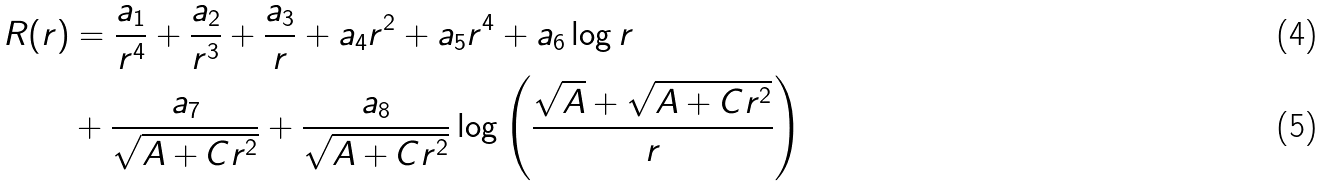<formula> <loc_0><loc_0><loc_500><loc_500>R ( r ) & = \frac { a _ { 1 } } { r ^ { 4 } } + \frac { a _ { 2 } } { r ^ { 3 } } + \frac { a _ { 3 } } { r } + a _ { 4 } r ^ { 2 } + a _ { 5 } r ^ { 4 } + a _ { 6 } \log r \\ & + \frac { a _ { 7 } } { \sqrt { A + C r ^ { 2 } } } + \frac { a _ { 8 } } { \sqrt { A + C r ^ { 2 } } } \log \left ( \frac { \sqrt { A } + \sqrt { A + C r ^ { 2 } } } { r } \right )</formula> 